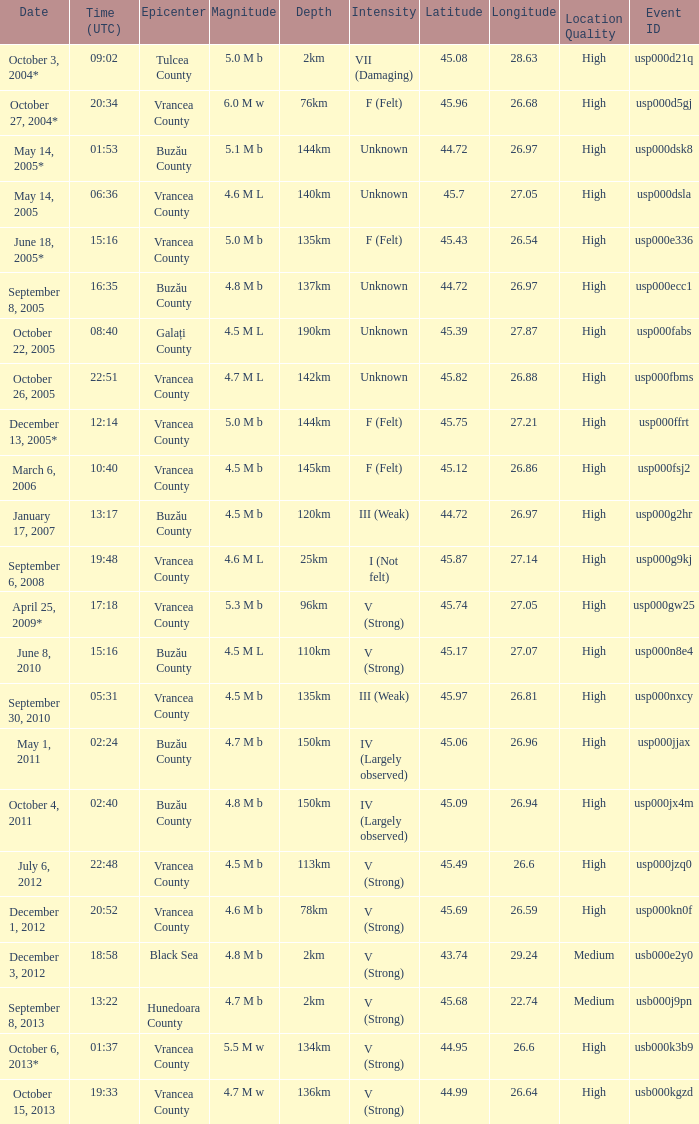What is the depth of the quake that occurred at 19:48? 25km. 